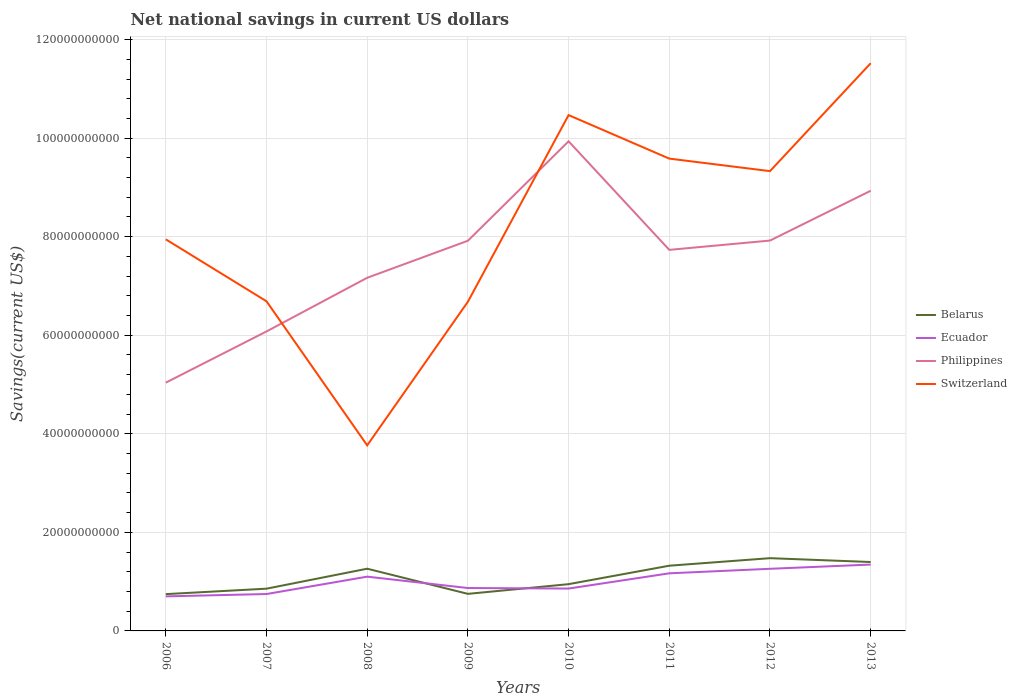Does the line corresponding to Ecuador intersect with the line corresponding to Philippines?
Give a very brief answer. No. Is the number of lines equal to the number of legend labels?
Provide a succinct answer. Yes. Across all years, what is the maximum net national savings in Belarus?
Keep it short and to the point. 7.47e+09. What is the total net national savings in Switzerland in the graph?
Offer a terse response. -3.79e+1. What is the difference between the highest and the second highest net national savings in Ecuador?
Ensure brevity in your answer.  6.46e+09. What is the difference between the highest and the lowest net national savings in Philippines?
Provide a succinct answer. 5. Is the net national savings in Philippines strictly greater than the net national savings in Switzerland over the years?
Keep it short and to the point. No. How many years are there in the graph?
Keep it short and to the point. 8. Does the graph contain any zero values?
Provide a succinct answer. No. Does the graph contain grids?
Make the answer very short. Yes. Where does the legend appear in the graph?
Your answer should be compact. Center right. How are the legend labels stacked?
Provide a succinct answer. Vertical. What is the title of the graph?
Your answer should be compact. Net national savings in current US dollars. What is the label or title of the Y-axis?
Make the answer very short. Savings(current US$). What is the Savings(current US$) in Belarus in 2006?
Your answer should be very brief. 7.47e+09. What is the Savings(current US$) in Ecuador in 2006?
Offer a terse response. 7.01e+09. What is the Savings(current US$) in Philippines in 2006?
Your answer should be very brief. 5.04e+1. What is the Savings(current US$) of Switzerland in 2006?
Keep it short and to the point. 7.95e+1. What is the Savings(current US$) in Belarus in 2007?
Ensure brevity in your answer.  8.57e+09. What is the Savings(current US$) of Ecuador in 2007?
Keep it short and to the point. 7.48e+09. What is the Savings(current US$) in Philippines in 2007?
Provide a succinct answer. 6.08e+1. What is the Savings(current US$) of Switzerland in 2007?
Give a very brief answer. 6.69e+1. What is the Savings(current US$) of Belarus in 2008?
Give a very brief answer. 1.26e+1. What is the Savings(current US$) of Ecuador in 2008?
Give a very brief answer. 1.10e+1. What is the Savings(current US$) of Philippines in 2008?
Your answer should be very brief. 7.17e+1. What is the Savings(current US$) in Switzerland in 2008?
Keep it short and to the point. 3.77e+1. What is the Savings(current US$) of Belarus in 2009?
Your answer should be compact. 7.52e+09. What is the Savings(current US$) of Ecuador in 2009?
Offer a very short reply. 8.71e+09. What is the Savings(current US$) of Philippines in 2009?
Make the answer very short. 7.92e+1. What is the Savings(current US$) in Switzerland in 2009?
Make the answer very short. 6.68e+1. What is the Savings(current US$) in Belarus in 2010?
Give a very brief answer. 9.49e+09. What is the Savings(current US$) of Ecuador in 2010?
Offer a terse response. 8.60e+09. What is the Savings(current US$) in Philippines in 2010?
Provide a succinct answer. 9.94e+1. What is the Savings(current US$) in Switzerland in 2010?
Give a very brief answer. 1.05e+11. What is the Savings(current US$) of Belarus in 2011?
Your answer should be very brief. 1.32e+1. What is the Savings(current US$) of Ecuador in 2011?
Make the answer very short. 1.17e+1. What is the Savings(current US$) in Philippines in 2011?
Offer a terse response. 7.73e+1. What is the Savings(current US$) of Switzerland in 2011?
Give a very brief answer. 9.58e+1. What is the Savings(current US$) of Belarus in 2012?
Offer a very short reply. 1.48e+1. What is the Savings(current US$) of Ecuador in 2012?
Offer a very short reply. 1.26e+1. What is the Savings(current US$) of Philippines in 2012?
Give a very brief answer. 7.92e+1. What is the Savings(current US$) of Switzerland in 2012?
Make the answer very short. 9.33e+1. What is the Savings(current US$) in Belarus in 2013?
Provide a short and direct response. 1.40e+1. What is the Savings(current US$) in Ecuador in 2013?
Provide a short and direct response. 1.35e+1. What is the Savings(current US$) of Philippines in 2013?
Provide a short and direct response. 8.93e+1. What is the Savings(current US$) in Switzerland in 2013?
Give a very brief answer. 1.15e+11. Across all years, what is the maximum Savings(current US$) in Belarus?
Give a very brief answer. 1.48e+1. Across all years, what is the maximum Savings(current US$) of Ecuador?
Ensure brevity in your answer.  1.35e+1. Across all years, what is the maximum Savings(current US$) of Philippines?
Your response must be concise. 9.94e+1. Across all years, what is the maximum Savings(current US$) of Switzerland?
Provide a short and direct response. 1.15e+11. Across all years, what is the minimum Savings(current US$) of Belarus?
Your response must be concise. 7.47e+09. Across all years, what is the minimum Savings(current US$) in Ecuador?
Offer a terse response. 7.01e+09. Across all years, what is the minimum Savings(current US$) of Philippines?
Keep it short and to the point. 5.04e+1. Across all years, what is the minimum Savings(current US$) in Switzerland?
Keep it short and to the point. 3.77e+1. What is the total Savings(current US$) in Belarus in the graph?
Your response must be concise. 8.77e+1. What is the total Savings(current US$) of Ecuador in the graph?
Make the answer very short. 8.06e+1. What is the total Savings(current US$) in Philippines in the graph?
Keep it short and to the point. 6.07e+11. What is the total Savings(current US$) in Switzerland in the graph?
Provide a succinct answer. 6.60e+11. What is the difference between the Savings(current US$) in Belarus in 2006 and that in 2007?
Your answer should be very brief. -1.11e+09. What is the difference between the Savings(current US$) in Ecuador in 2006 and that in 2007?
Provide a succinct answer. -4.76e+08. What is the difference between the Savings(current US$) in Philippines in 2006 and that in 2007?
Ensure brevity in your answer.  -1.04e+1. What is the difference between the Savings(current US$) of Switzerland in 2006 and that in 2007?
Provide a succinct answer. 1.26e+1. What is the difference between the Savings(current US$) of Belarus in 2006 and that in 2008?
Make the answer very short. -5.16e+09. What is the difference between the Savings(current US$) in Ecuador in 2006 and that in 2008?
Provide a succinct answer. -4.00e+09. What is the difference between the Savings(current US$) in Philippines in 2006 and that in 2008?
Make the answer very short. -2.13e+1. What is the difference between the Savings(current US$) of Switzerland in 2006 and that in 2008?
Give a very brief answer. 4.18e+1. What is the difference between the Savings(current US$) of Belarus in 2006 and that in 2009?
Give a very brief answer. -5.42e+07. What is the difference between the Savings(current US$) of Ecuador in 2006 and that in 2009?
Ensure brevity in your answer.  -1.70e+09. What is the difference between the Savings(current US$) of Philippines in 2006 and that in 2009?
Keep it short and to the point. -2.88e+1. What is the difference between the Savings(current US$) of Switzerland in 2006 and that in 2009?
Your answer should be very brief. 1.27e+1. What is the difference between the Savings(current US$) of Belarus in 2006 and that in 2010?
Provide a succinct answer. -2.02e+09. What is the difference between the Savings(current US$) of Ecuador in 2006 and that in 2010?
Your response must be concise. -1.59e+09. What is the difference between the Savings(current US$) in Philippines in 2006 and that in 2010?
Give a very brief answer. -4.90e+1. What is the difference between the Savings(current US$) of Switzerland in 2006 and that in 2010?
Give a very brief answer. -2.52e+1. What is the difference between the Savings(current US$) of Belarus in 2006 and that in 2011?
Ensure brevity in your answer.  -5.77e+09. What is the difference between the Savings(current US$) in Ecuador in 2006 and that in 2011?
Offer a very short reply. -4.68e+09. What is the difference between the Savings(current US$) in Philippines in 2006 and that in 2011?
Offer a terse response. -2.69e+1. What is the difference between the Savings(current US$) of Switzerland in 2006 and that in 2011?
Make the answer very short. -1.64e+1. What is the difference between the Savings(current US$) in Belarus in 2006 and that in 2012?
Make the answer very short. -7.30e+09. What is the difference between the Savings(current US$) of Ecuador in 2006 and that in 2012?
Provide a succinct answer. -5.60e+09. What is the difference between the Savings(current US$) of Philippines in 2006 and that in 2012?
Your answer should be compact. -2.88e+1. What is the difference between the Savings(current US$) in Switzerland in 2006 and that in 2012?
Keep it short and to the point. -1.38e+1. What is the difference between the Savings(current US$) of Belarus in 2006 and that in 2013?
Ensure brevity in your answer.  -6.52e+09. What is the difference between the Savings(current US$) of Ecuador in 2006 and that in 2013?
Give a very brief answer. -6.46e+09. What is the difference between the Savings(current US$) of Philippines in 2006 and that in 2013?
Your response must be concise. -3.89e+1. What is the difference between the Savings(current US$) in Switzerland in 2006 and that in 2013?
Provide a succinct answer. -3.57e+1. What is the difference between the Savings(current US$) of Belarus in 2007 and that in 2008?
Keep it short and to the point. -4.05e+09. What is the difference between the Savings(current US$) in Ecuador in 2007 and that in 2008?
Keep it short and to the point. -3.53e+09. What is the difference between the Savings(current US$) of Philippines in 2007 and that in 2008?
Make the answer very short. -1.09e+1. What is the difference between the Savings(current US$) of Switzerland in 2007 and that in 2008?
Provide a succinct answer. 2.92e+1. What is the difference between the Savings(current US$) in Belarus in 2007 and that in 2009?
Your answer should be compact. 1.05e+09. What is the difference between the Savings(current US$) in Ecuador in 2007 and that in 2009?
Provide a short and direct response. -1.22e+09. What is the difference between the Savings(current US$) of Philippines in 2007 and that in 2009?
Ensure brevity in your answer.  -1.84e+1. What is the difference between the Savings(current US$) of Switzerland in 2007 and that in 2009?
Offer a very short reply. 9.59e+07. What is the difference between the Savings(current US$) of Belarus in 2007 and that in 2010?
Your response must be concise. -9.17e+08. What is the difference between the Savings(current US$) in Ecuador in 2007 and that in 2010?
Provide a succinct answer. -1.11e+09. What is the difference between the Savings(current US$) of Philippines in 2007 and that in 2010?
Provide a short and direct response. -3.86e+1. What is the difference between the Savings(current US$) in Switzerland in 2007 and that in 2010?
Provide a short and direct response. -3.78e+1. What is the difference between the Savings(current US$) in Belarus in 2007 and that in 2011?
Your answer should be very brief. -4.66e+09. What is the difference between the Savings(current US$) of Ecuador in 2007 and that in 2011?
Your answer should be very brief. -4.20e+09. What is the difference between the Savings(current US$) of Philippines in 2007 and that in 2011?
Your answer should be compact. -1.66e+1. What is the difference between the Savings(current US$) of Switzerland in 2007 and that in 2011?
Keep it short and to the point. -2.89e+1. What is the difference between the Savings(current US$) in Belarus in 2007 and that in 2012?
Make the answer very short. -6.19e+09. What is the difference between the Savings(current US$) of Ecuador in 2007 and that in 2012?
Provide a succinct answer. -5.12e+09. What is the difference between the Savings(current US$) of Philippines in 2007 and that in 2012?
Your answer should be compact. -1.84e+1. What is the difference between the Savings(current US$) in Switzerland in 2007 and that in 2012?
Make the answer very short. -2.64e+1. What is the difference between the Savings(current US$) of Belarus in 2007 and that in 2013?
Give a very brief answer. -5.41e+09. What is the difference between the Savings(current US$) of Ecuador in 2007 and that in 2013?
Give a very brief answer. -5.98e+09. What is the difference between the Savings(current US$) of Philippines in 2007 and that in 2013?
Offer a terse response. -2.86e+1. What is the difference between the Savings(current US$) in Switzerland in 2007 and that in 2013?
Keep it short and to the point. -4.83e+1. What is the difference between the Savings(current US$) in Belarus in 2008 and that in 2009?
Your answer should be compact. 5.11e+09. What is the difference between the Savings(current US$) in Ecuador in 2008 and that in 2009?
Provide a succinct answer. 2.31e+09. What is the difference between the Savings(current US$) of Philippines in 2008 and that in 2009?
Offer a very short reply. -7.51e+09. What is the difference between the Savings(current US$) in Switzerland in 2008 and that in 2009?
Your answer should be very brief. -2.91e+1. What is the difference between the Savings(current US$) in Belarus in 2008 and that in 2010?
Give a very brief answer. 3.14e+09. What is the difference between the Savings(current US$) of Ecuador in 2008 and that in 2010?
Your answer should be compact. 2.42e+09. What is the difference between the Savings(current US$) in Philippines in 2008 and that in 2010?
Your response must be concise. -2.77e+1. What is the difference between the Savings(current US$) of Switzerland in 2008 and that in 2010?
Make the answer very short. -6.70e+1. What is the difference between the Savings(current US$) of Belarus in 2008 and that in 2011?
Your answer should be very brief. -6.08e+08. What is the difference between the Savings(current US$) of Ecuador in 2008 and that in 2011?
Keep it short and to the point. -6.76e+08. What is the difference between the Savings(current US$) of Philippines in 2008 and that in 2011?
Offer a terse response. -5.66e+09. What is the difference between the Savings(current US$) in Switzerland in 2008 and that in 2011?
Your answer should be compact. -5.82e+1. What is the difference between the Savings(current US$) of Belarus in 2008 and that in 2012?
Your answer should be compact. -2.14e+09. What is the difference between the Savings(current US$) in Ecuador in 2008 and that in 2012?
Ensure brevity in your answer.  -1.60e+09. What is the difference between the Savings(current US$) in Philippines in 2008 and that in 2012?
Your answer should be very brief. -7.55e+09. What is the difference between the Savings(current US$) in Switzerland in 2008 and that in 2012?
Your answer should be very brief. -5.57e+1. What is the difference between the Savings(current US$) in Belarus in 2008 and that in 2013?
Your response must be concise. -1.36e+09. What is the difference between the Savings(current US$) of Ecuador in 2008 and that in 2013?
Give a very brief answer. -2.45e+09. What is the difference between the Savings(current US$) of Philippines in 2008 and that in 2013?
Your response must be concise. -1.77e+1. What is the difference between the Savings(current US$) in Switzerland in 2008 and that in 2013?
Keep it short and to the point. -7.75e+1. What is the difference between the Savings(current US$) of Belarus in 2009 and that in 2010?
Keep it short and to the point. -1.97e+09. What is the difference between the Savings(current US$) of Ecuador in 2009 and that in 2010?
Provide a succinct answer. 1.08e+08. What is the difference between the Savings(current US$) in Philippines in 2009 and that in 2010?
Offer a terse response. -2.02e+1. What is the difference between the Savings(current US$) in Switzerland in 2009 and that in 2010?
Offer a very short reply. -3.79e+1. What is the difference between the Savings(current US$) of Belarus in 2009 and that in 2011?
Provide a succinct answer. -5.71e+09. What is the difference between the Savings(current US$) in Ecuador in 2009 and that in 2011?
Your response must be concise. -2.98e+09. What is the difference between the Savings(current US$) in Philippines in 2009 and that in 2011?
Your answer should be very brief. 1.85e+09. What is the difference between the Savings(current US$) of Switzerland in 2009 and that in 2011?
Provide a short and direct response. -2.90e+1. What is the difference between the Savings(current US$) of Belarus in 2009 and that in 2012?
Keep it short and to the point. -7.24e+09. What is the difference between the Savings(current US$) in Ecuador in 2009 and that in 2012?
Your answer should be very brief. -3.90e+09. What is the difference between the Savings(current US$) in Philippines in 2009 and that in 2012?
Give a very brief answer. -3.92e+07. What is the difference between the Savings(current US$) in Switzerland in 2009 and that in 2012?
Give a very brief answer. -2.65e+1. What is the difference between the Savings(current US$) of Belarus in 2009 and that in 2013?
Offer a terse response. -6.46e+09. What is the difference between the Savings(current US$) in Ecuador in 2009 and that in 2013?
Your response must be concise. -4.76e+09. What is the difference between the Savings(current US$) of Philippines in 2009 and that in 2013?
Your answer should be compact. -1.01e+1. What is the difference between the Savings(current US$) of Switzerland in 2009 and that in 2013?
Your answer should be very brief. -4.84e+1. What is the difference between the Savings(current US$) of Belarus in 2010 and that in 2011?
Your answer should be very brief. -3.74e+09. What is the difference between the Savings(current US$) in Ecuador in 2010 and that in 2011?
Ensure brevity in your answer.  -3.09e+09. What is the difference between the Savings(current US$) in Philippines in 2010 and that in 2011?
Offer a terse response. 2.20e+1. What is the difference between the Savings(current US$) of Switzerland in 2010 and that in 2011?
Offer a terse response. 8.83e+09. What is the difference between the Savings(current US$) in Belarus in 2010 and that in 2012?
Provide a short and direct response. -5.27e+09. What is the difference between the Savings(current US$) in Ecuador in 2010 and that in 2012?
Ensure brevity in your answer.  -4.01e+09. What is the difference between the Savings(current US$) in Philippines in 2010 and that in 2012?
Provide a short and direct response. 2.01e+1. What is the difference between the Savings(current US$) of Switzerland in 2010 and that in 2012?
Your response must be concise. 1.14e+1. What is the difference between the Savings(current US$) in Belarus in 2010 and that in 2013?
Offer a terse response. -4.49e+09. What is the difference between the Savings(current US$) in Ecuador in 2010 and that in 2013?
Your response must be concise. -4.87e+09. What is the difference between the Savings(current US$) in Philippines in 2010 and that in 2013?
Provide a succinct answer. 1.00e+1. What is the difference between the Savings(current US$) of Switzerland in 2010 and that in 2013?
Offer a very short reply. -1.05e+1. What is the difference between the Savings(current US$) of Belarus in 2011 and that in 2012?
Make the answer very short. -1.53e+09. What is the difference between the Savings(current US$) in Ecuador in 2011 and that in 2012?
Provide a short and direct response. -9.19e+08. What is the difference between the Savings(current US$) of Philippines in 2011 and that in 2012?
Offer a very short reply. -1.89e+09. What is the difference between the Savings(current US$) of Switzerland in 2011 and that in 2012?
Make the answer very short. 2.54e+09. What is the difference between the Savings(current US$) of Belarus in 2011 and that in 2013?
Ensure brevity in your answer.  -7.48e+08. What is the difference between the Savings(current US$) of Ecuador in 2011 and that in 2013?
Your response must be concise. -1.78e+09. What is the difference between the Savings(current US$) in Philippines in 2011 and that in 2013?
Offer a very short reply. -1.20e+1. What is the difference between the Savings(current US$) of Switzerland in 2011 and that in 2013?
Keep it short and to the point. -1.94e+1. What is the difference between the Savings(current US$) of Belarus in 2012 and that in 2013?
Your response must be concise. 7.80e+08. What is the difference between the Savings(current US$) of Ecuador in 2012 and that in 2013?
Give a very brief answer. -8.59e+08. What is the difference between the Savings(current US$) of Philippines in 2012 and that in 2013?
Your answer should be compact. -1.01e+1. What is the difference between the Savings(current US$) of Switzerland in 2012 and that in 2013?
Make the answer very short. -2.19e+1. What is the difference between the Savings(current US$) in Belarus in 2006 and the Savings(current US$) in Ecuador in 2007?
Offer a terse response. -1.79e+07. What is the difference between the Savings(current US$) of Belarus in 2006 and the Savings(current US$) of Philippines in 2007?
Provide a short and direct response. -5.33e+1. What is the difference between the Savings(current US$) in Belarus in 2006 and the Savings(current US$) in Switzerland in 2007?
Offer a terse response. -5.94e+1. What is the difference between the Savings(current US$) of Ecuador in 2006 and the Savings(current US$) of Philippines in 2007?
Your response must be concise. -5.38e+1. What is the difference between the Savings(current US$) of Ecuador in 2006 and the Savings(current US$) of Switzerland in 2007?
Provide a succinct answer. -5.99e+1. What is the difference between the Savings(current US$) in Philippines in 2006 and the Savings(current US$) in Switzerland in 2007?
Ensure brevity in your answer.  -1.65e+1. What is the difference between the Savings(current US$) of Belarus in 2006 and the Savings(current US$) of Ecuador in 2008?
Ensure brevity in your answer.  -3.55e+09. What is the difference between the Savings(current US$) of Belarus in 2006 and the Savings(current US$) of Philippines in 2008?
Make the answer very short. -6.42e+1. What is the difference between the Savings(current US$) in Belarus in 2006 and the Savings(current US$) in Switzerland in 2008?
Ensure brevity in your answer.  -3.02e+1. What is the difference between the Savings(current US$) in Ecuador in 2006 and the Savings(current US$) in Philippines in 2008?
Keep it short and to the point. -6.47e+1. What is the difference between the Savings(current US$) in Ecuador in 2006 and the Savings(current US$) in Switzerland in 2008?
Give a very brief answer. -3.06e+1. What is the difference between the Savings(current US$) in Philippines in 2006 and the Savings(current US$) in Switzerland in 2008?
Offer a terse response. 1.27e+1. What is the difference between the Savings(current US$) in Belarus in 2006 and the Savings(current US$) in Ecuador in 2009?
Keep it short and to the point. -1.24e+09. What is the difference between the Savings(current US$) in Belarus in 2006 and the Savings(current US$) in Philippines in 2009?
Your answer should be very brief. -7.17e+1. What is the difference between the Savings(current US$) in Belarus in 2006 and the Savings(current US$) in Switzerland in 2009?
Make the answer very short. -5.93e+1. What is the difference between the Savings(current US$) in Ecuador in 2006 and the Savings(current US$) in Philippines in 2009?
Your answer should be very brief. -7.22e+1. What is the difference between the Savings(current US$) in Ecuador in 2006 and the Savings(current US$) in Switzerland in 2009?
Make the answer very short. -5.98e+1. What is the difference between the Savings(current US$) in Philippines in 2006 and the Savings(current US$) in Switzerland in 2009?
Provide a short and direct response. -1.64e+1. What is the difference between the Savings(current US$) of Belarus in 2006 and the Savings(current US$) of Ecuador in 2010?
Your answer should be very brief. -1.13e+09. What is the difference between the Savings(current US$) of Belarus in 2006 and the Savings(current US$) of Philippines in 2010?
Give a very brief answer. -9.19e+1. What is the difference between the Savings(current US$) in Belarus in 2006 and the Savings(current US$) in Switzerland in 2010?
Offer a terse response. -9.72e+1. What is the difference between the Savings(current US$) of Ecuador in 2006 and the Savings(current US$) of Philippines in 2010?
Your response must be concise. -9.24e+1. What is the difference between the Savings(current US$) of Ecuador in 2006 and the Savings(current US$) of Switzerland in 2010?
Offer a terse response. -9.77e+1. What is the difference between the Savings(current US$) in Philippines in 2006 and the Savings(current US$) in Switzerland in 2010?
Give a very brief answer. -5.43e+1. What is the difference between the Savings(current US$) of Belarus in 2006 and the Savings(current US$) of Ecuador in 2011?
Your answer should be compact. -4.22e+09. What is the difference between the Savings(current US$) in Belarus in 2006 and the Savings(current US$) in Philippines in 2011?
Offer a terse response. -6.99e+1. What is the difference between the Savings(current US$) of Belarus in 2006 and the Savings(current US$) of Switzerland in 2011?
Keep it short and to the point. -8.84e+1. What is the difference between the Savings(current US$) of Ecuador in 2006 and the Savings(current US$) of Philippines in 2011?
Give a very brief answer. -7.03e+1. What is the difference between the Savings(current US$) of Ecuador in 2006 and the Savings(current US$) of Switzerland in 2011?
Your response must be concise. -8.88e+1. What is the difference between the Savings(current US$) of Philippines in 2006 and the Savings(current US$) of Switzerland in 2011?
Provide a short and direct response. -4.55e+1. What is the difference between the Savings(current US$) in Belarus in 2006 and the Savings(current US$) in Ecuador in 2012?
Provide a short and direct response. -5.14e+09. What is the difference between the Savings(current US$) in Belarus in 2006 and the Savings(current US$) in Philippines in 2012?
Your answer should be very brief. -7.17e+1. What is the difference between the Savings(current US$) of Belarus in 2006 and the Savings(current US$) of Switzerland in 2012?
Provide a succinct answer. -8.58e+1. What is the difference between the Savings(current US$) of Ecuador in 2006 and the Savings(current US$) of Philippines in 2012?
Your response must be concise. -7.22e+1. What is the difference between the Savings(current US$) in Ecuador in 2006 and the Savings(current US$) in Switzerland in 2012?
Provide a short and direct response. -8.63e+1. What is the difference between the Savings(current US$) of Philippines in 2006 and the Savings(current US$) of Switzerland in 2012?
Your answer should be compact. -4.29e+1. What is the difference between the Savings(current US$) of Belarus in 2006 and the Savings(current US$) of Ecuador in 2013?
Your answer should be compact. -6.00e+09. What is the difference between the Savings(current US$) in Belarus in 2006 and the Savings(current US$) in Philippines in 2013?
Offer a very short reply. -8.19e+1. What is the difference between the Savings(current US$) in Belarus in 2006 and the Savings(current US$) in Switzerland in 2013?
Offer a very short reply. -1.08e+11. What is the difference between the Savings(current US$) of Ecuador in 2006 and the Savings(current US$) of Philippines in 2013?
Your response must be concise. -8.23e+1. What is the difference between the Savings(current US$) in Ecuador in 2006 and the Savings(current US$) in Switzerland in 2013?
Your answer should be compact. -1.08e+11. What is the difference between the Savings(current US$) in Philippines in 2006 and the Savings(current US$) in Switzerland in 2013?
Make the answer very short. -6.48e+1. What is the difference between the Savings(current US$) in Belarus in 2007 and the Savings(current US$) in Ecuador in 2008?
Provide a succinct answer. -2.44e+09. What is the difference between the Savings(current US$) in Belarus in 2007 and the Savings(current US$) in Philippines in 2008?
Offer a terse response. -6.31e+1. What is the difference between the Savings(current US$) of Belarus in 2007 and the Savings(current US$) of Switzerland in 2008?
Offer a very short reply. -2.91e+1. What is the difference between the Savings(current US$) of Ecuador in 2007 and the Savings(current US$) of Philippines in 2008?
Give a very brief answer. -6.42e+1. What is the difference between the Savings(current US$) in Ecuador in 2007 and the Savings(current US$) in Switzerland in 2008?
Provide a succinct answer. -3.02e+1. What is the difference between the Savings(current US$) of Philippines in 2007 and the Savings(current US$) of Switzerland in 2008?
Keep it short and to the point. 2.31e+1. What is the difference between the Savings(current US$) in Belarus in 2007 and the Savings(current US$) in Ecuador in 2009?
Offer a very short reply. -1.33e+08. What is the difference between the Savings(current US$) in Belarus in 2007 and the Savings(current US$) in Philippines in 2009?
Your response must be concise. -7.06e+1. What is the difference between the Savings(current US$) in Belarus in 2007 and the Savings(current US$) in Switzerland in 2009?
Provide a succinct answer. -5.82e+1. What is the difference between the Savings(current US$) of Ecuador in 2007 and the Savings(current US$) of Philippines in 2009?
Your answer should be compact. -7.17e+1. What is the difference between the Savings(current US$) in Ecuador in 2007 and the Savings(current US$) in Switzerland in 2009?
Make the answer very short. -5.93e+1. What is the difference between the Savings(current US$) of Philippines in 2007 and the Savings(current US$) of Switzerland in 2009?
Your answer should be very brief. -6.03e+09. What is the difference between the Savings(current US$) in Belarus in 2007 and the Savings(current US$) in Ecuador in 2010?
Your answer should be compact. -2.52e+07. What is the difference between the Savings(current US$) of Belarus in 2007 and the Savings(current US$) of Philippines in 2010?
Provide a short and direct response. -9.08e+1. What is the difference between the Savings(current US$) in Belarus in 2007 and the Savings(current US$) in Switzerland in 2010?
Your answer should be very brief. -9.61e+1. What is the difference between the Savings(current US$) of Ecuador in 2007 and the Savings(current US$) of Philippines in 2010?
Make the answer very short. -9.19e+1. What is the difference between the Savings(current US$) in Ecuador in 2007 and the Savings(current US$) in Switzerland in 2010?
Keep it short and to the point. -9.72e+1. What is the difference between the Savings(current US$) in Philippines in 2007 and the Savings(current US$) in Switzerland in 2010?
Give a very brief answer. -4.39e+1. What is the difference between the Savings(current US$) in Belarus in 2007 and the Savings(current US$) in Ecuador in 2011?
Make the answer very short. -3.12e+09. What is the difference between the Savings(current US$) in Belarus in 2007 and the Savings(current US$) in Philippines in 2011?
Your answer should be compact. -6.88e+1. What is the difference between the Savings(current US$) in Belarus in 2007 and the Savings(current US$) in Switzerland in 2011?
Provide a succinct answer. -8.73e+1. What is the difference between the Savings(current US$) of Ecuador in 2007 and the Savings(current US$) of Philippines in 2011?
Ensure brevity in your answer.  -6.98e+1. What is the difference between the Savings(current US$) in Ecuador in 2007 and the Savings(current US$) in Switzerland in 2011?
Make the answer very short. -8.84e+1. What is the difference between the Savings(current US$) in Philippines in 2007 and the Savings(current US$) in Switzerland in 2011?
Offer a very short reply. -3.51e+1. What is the difference between the Savings(current US$) in Belarus in 2007 and the Savings(current US$) in Ecuador in 2012?
Provide a succinct answer. -4.04e+09. What is the difference between the Savings(current US$) of Belarus in 2007 and the Savings(current US$) of Philippines in 2012?
Provide a succinct answer. -7.06e+1. What is the difference between the Savings(current US$) of Belarus in 2007 and the Savings(current US$) of Switzerland in 2012?
Your answer should be very brief. -8.47e+1. What is the difference between the Savings(current US$) in Ecuador in 2007 and the Savings(current US$) in Philippines in 2012?
Your response must be concise. -7.17e+1. What is the difference between the Savings(current US$) in Ecuador in 2007 and the Savings(current US$) in Switzerland in 2012?
Keep it short and to the point. -8.58e+1. What is the difference between the Savings(current US$) in Philippines in 2007 and the Savings(current US$) in Switzerland in 2012?
Offer a very short reply. -3.25e+1. What is the difference between the Savings(current US$) in Belarus in 2007 and the Savings(current US$) in Ecuador in 2013?
Offer a terse response. -4.89e+09. What is the difference between the Savings(current US$) of Belarus in 2007 and the Savings(current US$) of Philippines in 2013?
Your answer should be very brief. -8.07e+1. What is the difference between the Savings(current US$) of Belarus in 2007 and the Savings(current US$) of Switzerland in 2013?
Give a very brief answer. -1.07e+11. What is the difference between the Savings(current US$) of Ecuador in 2007 and the Savings(current US$) of Philippines in 2013?
Make the answer very short. -8.18e+1. What is the difference between the Savings(current US$) in Ecuador in 2007 and the Savings(current US$) in Switzerland in 2013?
Provide a short and direct response. -1.08e+11. What is the difference between the Savings(current US$) of Philippines in 2007 and the Savings(current US$) of Switzerland in 2013?
Keep it short and to the point. -5.44e+1. What is the difference between the Savings(current US$) in Belarus in 2008 and the Savings(current US$) in Ecuador in 2009?
Provide a succinct answer. 3.92e+09. What is the difference between the Savings(current US$) in Belarus in 2008 and the Savings(current US$) in Philippines in 2009?
Your response must be concise. -6.65e+1. What is the difference between the Savings(current US$) of Belarus in 2008 and the Savings(current US$) of Switzerland in 2009?
Offer a terse response. -5.42e+1. What is the difference between the Savings(current US$) of Ecuador in 2008 and the Savings(current US$) of Philippines in 2009?
Keep it short and to the point. -6.82e+1. What is the difference between the Savings(current US$) in Ecuador in 2008 and the Savings(current US$) in Switzerland in 2009?
Provide a succinct answer. -5.58e+1. What is the difference between the Savings(current US$) in Philippines in 2008 and the Savings(current US$) in Switzerland in 2009?
Your answer should be compact. 4.86e+09. What is the difference between the Savings(current US$) in Belarus in 2008 and the Savings(current US$) in Ecuador in 2010?
Make the answer very short. 4.03e+09. What is the difference between the Savings(current US$) of Belarus in 2008 and the Savings(current US$) of Philippines in 2010?
Offer a very short reply. -8.67e+1. What is the difference between the Savings(current US$) of Belarus in 2008 and the Savings(current US$) of Switzerland in 2010?
Provide a succinct answer. -9.20e+1. What is the difference between the Savings(current US$) in Ecuador in 2008 and the Savings(current US$) in Philippines in 2010?
Your answer should be compact. -8.83e+1. What is the difference between the Savings(current US$) in Ecuador in 2008 and the Savings(current US$) in Switzerland in 2010?
Keep it short and to the point. -9.37e+1. What is the difference between the Savings(current US$) of Philippines in 2008 and the Savings(current US$) of Switzerland in 2010?
Your response must be concise. -3.30e+1. What is the difference between the Savings(current US$) of Belarus in 2008 and the Savings(current US$) of Ecuador in 2011?
Keep it short and to the point. 9.37e+08. What is the difference between the Savings(current US$) of Belarus in 2008 and the Savings(current US$) of Philippines in 2011?
Provide a short and direct response. -6.47e+1. What is the difference between the Savings(current US$) in Belarus in 2008 and the Savings(current US$) in Switzerland in 2011?
Keep it short and to the point. -8.32e+1. What is the difference between the Savings(current US$) in Ecuador in 2008 and the Savings(current US$) in Philippines in 2011?
Provide a succinct answer. -6.63e+1. What is the difference between the Savings(current US$) of Ecuador in 2008 and the Savings(current US$) of Switzerland in 2011?
Keep it short and to the point. -8.48e+1. What is the difference between the Savings(current US$) of Philippines in 2008 and the Savings(current US$) of Switzerland in 2011?
Offer a very short reply. -2.42e+1. What is the difference between the Savings(current US$) in Belarus in 2008 and the Savings(current US$) in Ecuador in 2012?
Offer a terse response. 1.78e+07. What is the difference between the Savings(current US$) in Belarus in 2008 and the Savings(current US$) in Philippines in 2012?
Offer a very short reply. -6.66e+1. What is the difference between the Savings(current US$) of Belarus in 2008 and the Savings(current US$) of Switzerland in 2012?
Your answer should be very brief. -8.07e+1. What is the difference between the Savings(current US$) of Ecuador in 2008 and the Savings(current US$) of Philippines in 2012?
Offer a terse response. -6.82e+1. What is the difference between the Savings(current US$) of Ecuador in 2008 and the Savings(current US$) of Switzerland in 2012?
Give a very brief answer. -8.23e+1. What is the difference between the Savings(current US$) of Philippines in 2008 and the Savings(current US$) of Switzerland in 2012?
Ensure brevity in your answer.  -2.16e+1. What is the difference between the Savings(current US$) of Belarus in 2008 and the Savings(current US$) of Ecuador in 2013?
Ensure brevity in your answer.  -8.41e+08. What is the difference between the Savings(current US$) in Belarus in 2008 and the Savings(current US$) in Philippines in 2013?
Keep it short and to the point. -7.67e+1. What is the difference between the Savings(current US$) of Belarus in 2008 and the Savings(current US$) of Switzerland in 2013?
Offer a terse response. -1.03e+11. What is the difference between the Savings(current US$) of Ecuador in 2008 and the Savings(current US$) of Philippines in 2013?
Your answer should be very brief. -7.83e+1. What is the difference between the Savings(current US$) of Ecuador in 2008 and the Savings(current US$) of Switzerland in 2013?
Make the answer very short. -1.04e+11. What is the difference between the Savings(current US$) in Philippines in 2008 and the Savings(current US$) in Switzerland in 2013?
Offer a very short reply. -4.35e+1. What is the difference between the Savings(current US$) in Belarus in 2009 and the Savings(current US$) in Ecuador in 2010?
Provide a short and direct response. -1.08e+09. What is the difference between the Savings(current US$) in Belarus in 2009 and the Savings(current US$) in Philippines in 2010?
Offer a very short reply. -9.18e+1. What is the difference between the Savings(current US$) of Belarus in 2009 and the Savings(current US$) of Switzerland in 2010?
Offer a terse response. -9.72e+1. What is the difference between the Savings(current US$) of Ecuador in 2009 and the Savings(current US$) of Philippines in 2010?
Keep it short and to the point. -9.07e+1. What is the difference between the Savings(current US$) in Ecuador in 2009 and the Savings(current US$) in Switzerland in 2010?
Your answer should be compact. -9.60e+1. What is the difference between the Savings(current US$) in Philippines in 2009 and the Savings(current US$) in Switzerland in 2010?
Make the answer very short. -2.55e+1. What is the difference between the Savings(current US$) of Belarus in 2009 and the Savings(current US$) of Ecuador in 2011?
Make the answer very short. -4.17e+09. What is the difference between the Savings(current US$) of Belarus in 2009 and the Savings(current US$) of Philippines in 2011?
Make the answer very short. -6.98e+1. What is the difference between the Savings(current US$) of Belarus in 2009 and the Savings(current US$) of Switzerland in 2011?
Your answer should be compact. -8.83e+1. What is the difference between the Savings(current US$) of Ecuador in 2009 and the Savings(current US$) of Philippines in 2011?
Provide a short and direct response. -6.86e+1. What is the difference between the Savings(current US$) of Ecuador in 2009 and the Savings(current US$) of Switzerland in 2011?
Your answer should be very brief. -8.71e+1. What is the difference between the Savings(current US$) of Philippines in 2009 and the Savings(current US$) of Switzerland in 2011?
Your answer should be very brief. -1.67e+1. What is the difference between the Savings(current US$) in Belarus in 2009 and the Savings(current US$) in Ecuador in 2012?
Your answer should be compact. -5.09e+09. What is the difference between the Savings(current US$) in Belarus in 2009 and the Savings(current US$) in Philippines in 2012?
Offer a very short reply. -7.17e+1. What is the difference between the Savings(current US$) of Belarus in 2009 and the Savings(current US$) of Switzerland in 2012?
Provide a succinct answer. -8.58e+1. What is the difference between the Savings(current US$) in Ecuador in 2009 and the Savings(current US$) in Philippines in 2012?
Provide a succinct answer. -7.05e+1. What is the difference between the Savings(current US$) in Ecuador in 2009 and the Savings(current US$) in Switzerland in 2012?
Your answer should be very brief. -8.46e+1. What is the difference between the Savings(current US$) in Philippines in 2009 and the Savings(current US$) in Switzerland in 2012?
Make the answer very short. -1.41e+1. What is the difference between the Savings(current US$) in Belarus in 2009 and the Savings(current US$) in Ecuador in 2013?
Offer a very short reply. -5.95e+09. What is the difference between the Savings(current US$) of Belarus in 2009 and the Savings(current US$) of Philippines in 2013?
Offer a terse response. -8.18e+1. What is the difference between the Savings(current US$) of Belarus in 2009 and the Savings(current US$) of Switzerland in 2013?
Your answer should be compact. -1.08e+11. What is the difference between the Savings(current US$) in Ecuador in 2009 and the Savings(current US$) in Philippines in 2013?
Offer a very short reply. -8.06e+1. What is the difference between the Savings(current US$) in Ecuador in 2009 and the Savings(current US$) in Switzerland in 2013?
Your answer should be compact. -1.06e+11. What is the difference between the Savings(current US$) in Philippines in 2009 and the Savings(current US$) in Switzerland in 2013?
Your answer should be compact. -3.60e+1. What is the difference between the Savings(current US$) in Belarus in 2010 and the Savings(current US$) in Ecuador in 2011?
Give a very brief answer. -2.20e+09. What is the difference between the Savings(current US$) of Belarus in 2010 and the Savings(current US$) of Philippines in 2011?
Offer a terse response. -6.78e+1. What is the difference between the Savings(current US$) in Belarus in 2010 and the Savings(current US$) in Switzerland in 2011?
Your answer should be very brief. -8.64e+1. What is the difference between the Savings(current US$) of Ecuador in 2010 and the Savings(current US$) of Philippines in 2011?
Your answer should be compact. -6.87e+1. What is the difference between the Savings(current US$) of Ecuador in 2010 and the Savings(current US$) of Switzerland in 2011?
Ensure brevity in your answer.  -8.72e+1. What is the difference between the Savings(current US$) of Philippines in 2010 and the Savings(current US$) of Switzerland in 2011?
Make the answer very short. 3.52e+09. What is the difference between the Savings(current US$) in Belarus in 2010 and the Savings(current US$) in Ecuador in 2012?
Your answer should be compact. -3.12e+09. What is the difference between the Savings(current US$) of Belarus in 2010 and the Savings(current US$) of Philippines in 2012?
Provide a short and direct response. -6.97e+1. What is the difference between the Savings(current US$) in Belarus in 2010 and the Savings(current US$) in Switzerland in 2012?
Give a very brief answer. -8.38e+1. What is the difference between the Savings(current US$) in Ecuador in 2010 and the Savings(current US$) in Philippines in 2012?
Provide a short and direct response. -7.06e+1. What is the difference between the Savings(current US$) in Ecuador in 2010 and the Savings(current US$) in Switzerland in 2012?
Your answer should be compact. -8.47e+1. What is the difference between the Savings(current US$) in Philippines in 2010 and the Savings(current US$) in Switzerland in 2012?
Provide a short and direct response. 6.06e+09. What is the difference between the Savings(current US$) of Belarus in 2010 and the Savings(current US$) of Ecuador in 2013?
Ensure brevity in your answer.  -3.98e+09. What is the difference between the Savings(current US$) of Belarus in 2010 and the Savings(current US$) of Philippines in 2013?
Your answer should be compact. -7.98e+1. What is the difference between the Savings(current US$) of Belarus in 2010 and the Savings(current US$) of Switzerland in 2013?
Your response must be concise. -1.06e+11. What is the difference between the Savings(current US$) of Ecuador in 2010 and the Savings(current US$) of Philippines in 2013?
Your response must be concise. -8.07e+1. What is the difference between the Savings(current US$) of Ecuador in 2010 and the Savings(current US$) of Switzerland in 2013?
Offer a very short reply. -1.07e+11. What is the difference between the Savings(current US$) of Philippines in 2010 and the Savings(current US$) of Switzerland in 2013?
Your response must be concise. -1.58e+1. What is the difference between the Savings(current US$) in Belarus in 2011 and the Savings(current US$) in Ecuador in 2012?
Provide a succinct answer. 6.25e+08. What is the difference between the Savings(current US$) of Belarus in 2011 and the Savings(current US$) of Philippines in 2012?
Keep it short and to the point. -6.60e+1. What is the difference between the Savings(current US$) in Belarus in 2011 and the Savings(current US$) in Switzerland in 2012?
Your answer should be compact. -8.01e+1. What is the difference between the Savings(current US$) in Ecuador in 2011 and the Savings(current US$) in Philippines in 2012?
Make the answer very short. -6.75e+1. What is the difference between the Savings(current US$) of Ecuador in 2011 and the Savings(current US$) of Switzerland in 2012?
Your answer should be very brief. -8.16e+1. What is the difference between the Savings(current US$) in Philippines in 2011 and the Savings(current US$) in Switzerland in 2012?
Offer a terse response. -1.60e+1. What is the difference between the Savings(current US$) of Belarus in 2011 and the Savings(current US$) of Ecuador in 2013?
Your answer should be very brief. -2.33e+08. What is the difference between the Savings(current US$) in Belarus in 2011 and the Savings(current US$) in Philippines in 2013?
Provide a succinct answer. -7.61e+1. What is the difference between the Savings(current US$) in Belarus in 2011 and the Savings(current US$) in Switzerland in 2013?
Provide a short and direct response. -1.02e+11. What is the difference between the Savings(current US$) in Ecuador in 2011 and the Savings(current US$) in Philippines in 2013?
Provide a succinct answer. -7.76e+1. What is the difference between the Savings(current US$) in Ecuador in 2011 and the Savings(current US$) in Switzerland in 2013?
Ensure brevity in your answer.  -1.04e+11. What is the difference between the Savings(current US$) in Philippines in 2011 and the Savings(current US$) in Switzerland in 2013?
Make the answer very short. -3.79e+1. What is the difference between the Savings(current US$) in Belarus in 2012 and the Savings(current US$) in Ecuador in 2013?
Your answer should be compact. 1.29e+09. What is the difference between the Savings(current US$) in Belarus in 2012 and the Savings(current US$) in Philippines in 2013?
Give a very brief answer. -7.46e+1. What is the difference between the Savings(current US$) in Belarus in 2012 and the Savings(current US$) in Switzerland in 2013?
Offer a terse response. -1.00e+11. What is the difference between the Savings(current US$) in Ecuador in 2012 and the Savings(current US$) in Philippines in 2013?
Your answer should be very brief. -7.67e+1. What is the difference between the Savings(current US$) of Ecuador in 2012 and the Savings(current US$) of Switzerland in 2013?
Make the answer very short. -1.03e+11. What is the difference between the Savings(current US$) of Philippines in 2012 and the Savings(current US$) of Switzerland in 2013?
Offer a very short reply. -3.60e+1. What is the average Savings(current US$) of Belarus per year?
Provide a succinct answer. 1.10e+1. What is the average Savings(current US$) in Ecuador per year?
Give a very brief answer. 1.01e+1. What is the average Savings(current US$) of Philippines per year?
Ensure brevity in your answer.  7.59e+1. What is the average Savings(current US$) in Switzerland per year?
Make the answer very short. 8.25e+1. In the year 2006, what is the difference between the Savings(current US$) in Belarus and Savings(current US$) in Ecuador?
Ensure brevity in your answer.  4.58e+08. In the year 2006, what is the difference between the Savings(current US$) of Belarus and Savings(current US$) of Philippines?
Make the answer very short. -4.29e+1. In the year 2006, what is the difference between the Savings(current US$) in Belarus and Savings(current US$) in Switzerland?
Your response must be concise. -7.20e+1. In the year 2006, what is the difference between the Savings(current US$) of Ecuador and Savings(current US$) of Philippines?
Your response must be concise. -4.34e+1. In the year 2006, what is the difference between the Savings(current US$) in Ecuador and Savings(current US$) in Switzerland?
Keep it short and to the point. -7.25e+1. In the year 2006, what is the difference between the Savings(current US$) of Philippines and Savings(current US$) of Switzerland?
Make the answer very short. -2.91e+1. In the year 2007, what is the difference between the Savings(current US$) in Belarus and Savings(current US$) in Ecuador?
Give a very brief answer. 1.09e+09. In the year 2007, what is the difference between the Savings(current US$) in Belarus and Savings(current US$) in Philippines?
Offer a very short reply. -5.22e+1. In the year 2007, what is the difference between the Savings(current US$) of Belarus and Savings(current US$) of Switzerland?
Your answer should be very brief. -5.83e+1. In the year 2007, what is the difference between the Savings(current US$) of Ecuador and Savings(current US$) of Philippines?
Your response must be concise. -5.33e+1. In the year 2007, what is the difference between the Savings(current US$) in Ecuador and Savings(current US$) in Switzerland?
Keep it short and to the point. -5.94e+1. In the year 2007, what is the difference between the Savings(current US$) of Philippines and Savings(current US$) of Switzerland?
Offer a terse response. -6.13e+09. In the year 2008, what is the difference between the Savings(current US$) in Belarus and Savings(current US$) in Ecuador?
Your answer should be very brief. 1.61e+09. In the year 2008, what is the difference between the Savings(current US$) of Belarus and Savings(current US$) of Philippines?
Offer a very short reply. -5.90e+1. In the year 2008, what is the difference between the Savings(current US$) in Belarus and Savings(current US$) in Switzerland?
Give a very brief answer. -2.50e+1. In the year 2008, what is the difference between the Savings(current US$) of Ecuador and Savings(current US$) of Philippines?
Provide a short and direct response. -6.06e+1. In the year 2008, what is the difference between the Savings(current US$) in Ecuador and Savings(current US$) in Switzerland?
Your response must be concise. -2.66e+1. In the year 2008, what is the difference between the Savings(current US$) of Philippines and Savings(current US$) of Switzerland?
Your answer should be compact. 3.40e+1. In the year 2009, what is the difference between the Savings(current US$) in Belarus and Savings(current US$) in Ecuador?
Offer a very short reply. -1.18e+09. In the year 2009, what is the difference between the Savings(current US$) in Belarus and Savings(current US$) in Philippines?
Ensure brevity in your answer.  -7.17e+1. In the year 2009, what is the difference between the Savings(current US$) of Belarus and Savings(current US$) of Switzerland?
Your response must be concise. -5.93e+1. In the year 2009, what is the difference between the Savings(current US$) in Ecuador and Savings(current US$) in Philippines?
Make the answer very short. -7.05e+1. In the year 2009, what is the difference between the Savings(current US$) of Ecuador and Savings(current US$) of Switzerland?
Your response must be concise. -5.81e+1. In the year 2009, what is the difference between the Savings(current US$) in Philippines and Savings(current US$) in Switzerland?
Make the answer very short. 1.24e+1. In the year 2010, what is the difference between the Savings(current US$) of Belarus and Savings(current US$) of Ecuador?
Provide a short and direct response. 8.92e+08. In the year 2010, what is the difference between the Savings(current US$) of Belarus and Savings(current US$) of Philippines?
Give a very brief answer. -8.99e+1. In the year 2010, what is the difference between the Savings(current US$) in Belarus and Savings(current US$) in Switzerland?
Provide a short and direct response. -9.52e+1. In the year 2010, what is the difference between the Savings(current US$) of Ecuador and Savings(current US$) of Philippines?
Offer a terse response. -9.08e+1. In the year 2010, what is the difference between the Savings(current US$) in Ecuador and Savings(current US$) in Switzerland?
Make the answer very short. -9.61e+1. In the year 2010, what is the difference between the Savings(current US$) in Philippines and Savings(current US$) in Switzerland?
Your answer should be compact. -5.32e+09. In the year 2011, what is the difference between the Savings(current US$) in Belarus and Savings(current US$) in Ecuador?
Provide a short and direct response. 1.54e+09. In the year 2011, what is the difference between the Savings(current US$) in Belarus and Savings(current US$) in Philippines?
Offer a very short reply. -6.41e+1. In the year 2011, what is the difference between the Savings(current US$) in Belarus and Savings(current US$) in Switzerland?
Ensure brevity in your answer.  -8.26e+1. In the year 2011, what is the difference between the Savings(current US$) of Ecuador and Savings(current US$) of Philippines?
Keep it short and to the point. -6.56e+1. In the year 2011, what is the difference between the Savings(current US$) in Ecuador and Savings(current US$) in Switzerland?
Provide a succinct answer. -8.42e+1. In the year 2011, what is the difference between the Savings(current US$) in Philippines and Savings(current US$) in Switzerland?
Give a very brief answer. -1.85e+1. In the year 2012, what is the difference between the Savings(current US$) of Belarus and Savings(current US$) of Ecuador?
Your answer should be very brief. 2.15e+09. In the year 2012, what is the difference between the Savings(current US$) of Belarus and Savings(current US$) of Philippines?
Make the answer very short. -6.45e+1. In the year 2012, what is the difference between the Savings(current US$) of Belarus and Savings(current US$) of Switzerland?
Ensure brevity in your answer.  -7.85e+1. In the year 2012, what is the difference between the Savings(current US$) in Ecuador and Savings(current US$) in Philippines?
Your answer should be compact. -6.66e+1. In the year 2012, what is the difference between the Savings(current US$) in Ecuador and Savings(current US$) in Switzerland?
Give a very brief answer. -8.07e+1. In the year 2012, what is the difference between the Savings(current US$) in Philippines and Savings(current US$) in Switzerland?
Your answer should be compact. -1.41e+1. In the year 2013, what is the difference between the Savings(current US$) of Belarus and Savings(current US$) of Ecuador?
Give a very brief answer. 5.15e+08. In the year 2013, what is the difference between the Savings(current US$) in Belarus and Savings(current US$) in Philippines?
Give a very brief answer. -7.53e+1. In the year 2013, what is the difference between the Savings(current US$) in Belarus and Savings(current US$) in Switzerland?
Your answer should be compact. -1.01e+11. In the year 2013, what is the difference between the Savings(current US$) of Ecuador and Savings(current US$) of Philippines?
Offer a terse response. -7.59e+1. In the year 2013, what is the difference between the Savings(current US$) in Ecuador and Savings(current US$) in Switzerland?
Provide a succinct answer. -1.02e+11. In the year 2013, what is the difference between the Savings(current US$) of Philippines and Savings(current US$) of Switzerland?
Ensure brevity in your answer.  -2.59e+1. What is the ratio of the Savings(current US$) in Belarus in 2006 to that in 2007?
Provide a short and direct response. 0.87. What is the ratio of the Savings(current US$) in Ecuador in 2006 to that in 2007?
Keep it short and to the point. 0.94. What is the ratio of the Savings(current US$) of Philippines in 2006 to that in 2007?
Provide a short and direct response. 0.83. What is the ratio of the Savings(current US$) of Switzerland in 2006 to that in 2007?
Keep it short and to the point. 1.19. What is the ratio of the Savings(current US$) in Belarus in 2006 to that in 2008?
Give a very brief answer. 0.59. What is the ratio of the Savings(current US$) in Ecuador in 2006 to that in 2008?
Your answer should be very brief. 0.64. What is the ratio of the Savings(current US$) of Philippines in 2006 to that in 2008?
Ensure brevity in your answer.  0.7. What is the ratio of the Savings(current US$) in Switzerland in 2006 to that in 2008?
Make the answer very short. 2.11. What is the ratio of the Savings(current US$) of Ecuador in 2006 to that in 2009?
Provide a succinct answer. 0.81. What is the ratio of the Savings(current US$) of Philippines in 2006 to that in 2009?
Your answer should be compact. 0.64. What is the ratio of the Savings(current US$) in Switzerland in 2006 to that in 2009?
Offer a terse response. 1.19. What is the ratio of the Savings(current US$) in Belarus in 2006 to that in 2010?
Make the answer very short. 0.79. What is the ratio of the Savings(current US$) in Ecuador in 2006 to that in 2010?
Offer a terse response. 0.82. What is the ratio of the Savings(current US$) of Philippines in 2006 to that in 2010?
Ensure brevity in your answer.  0.51. What is the ratio of the Savings(current US$) in Switzerland in 2006 to that in 2010?
Give a very brief answer. 0.76. What is the ratio of the Savings(current US$) of Belarus in 2006 to that in 2011?
Offer a very short reply. 0.56. What is the ratio of the Savings(current US$) in Ecuador in 2006 to that in 2011?
Offer a very short reply. 0.6. What is the ratio of the Savings(current US$) in Philippines in 2006 to that in 2011?
Provide a short and direct response. 0.65. What is the ratio of the Savings(current US$) in Switzerland in 2006 to that in 2011?
Your answer should be very brief. 0.83. What is the ratio of the Savings(current US$) in Belarus in 2006 to that in 2012?
Provide a short and direct response. 0.51. What is the ratio of the Savings(current US$) of Ecuador in 2006 to that in 2012?
Offer a terse response. 0.56. What is the ratio of the Savings(current US$) in Philippines in 2006 to that in 2012?
Offer a very short reply. 0.64. What is the ratio of the Savings(current US$) in Switzerland in 2006 to that in 2012?
Offer a very short reply. 0.85. What is the ratio of the Savings(current US$) of Belarus in 2006 to that in 2013?
Your response must be concise. 0.53. What is the ratio of the Savings(current US$) of Ecuador in 2006 to that in 2013?
Keep it short and to the point. 0.52. What is the ratio of the Savings(current US$) of Philippines in 2006 to that in 2013?
Your response must be concise. 0.56. What is the ratio of the Savings(current US$) of Switzerland in 2006 to that in 2013?
Provide a succinct answer. 0.69. What is the ratio of the Savings(current US$) in Belarus in 2007 to that in 2008?
Make the answer very short. 0.68. What is the ratio of the Savings(current US$) in Ecuador in 2007 to that in 2008?
Ensure brevity in your answer.  0.68. What is the ratio of the Savings(current US$) of Philippines in 2007 to that in 2008?
Offer a terse response. 0.85. What is the ratio of the Savings(current US$) in Switzerland in 2007 to that in 2008?
Offer a terse response. 1.78. What is the ratio of the Savings(current US$) of Belarus in 2007 to that in 2009?
Give a very brief answer. 1.14. What is the ratio of the Savings(current US$) in Ecuador in 2007 to that in 2009?
Ensure brevity in your answer.  0.86. What is the ratio of the Savings(current US$) of Philippines in 2007 to that in 2009?
Make the answer very short. 0.77. What is the ratio of the Savings(current US$) in Belarus in 2007 to that in 2010?
Make the answer very short. 0.9. What is the ratio of the Savings(current US$) of Ecuador in 2007 to that in 2010?
Keep it short and to the point. 0.87. What is the ratio of the Savings(current US$) of Philippines in 2007 to that in 2010?
Keep it short and to the point. 0.61. What is the ratio of the Savings(current US$) in Switzerland in 2007 to that in 2010?
Give a very brief answer. 0.64. What is the ratio of the Savings(current US$) of Belarus in 2007 to that in 2011?
Ensure brevity in your answer.  0.65. What is the ratio of the Savings(current US$) of Ecuador in 2007 to that in 2011?
Provide a succinct answer. 0.64. What is the ratio of the Savings(current US$) of Philippines in 2007 to that in 2011?
Your answer should be compact. 0.79. What is the ratio of the Savings(current US$) in Switzerland in 2007 to that in 2011?
Ensure brevity in your answer.  0.7. What is the ratio of the Savings(current US$) in Belarus in 2007 to that in 2012?
Offer a very short reply. 0.58. What is the ratio of the Savings(current US$) of Ecuador in 2007 to that in 2012?
Your response must be concise. 0.59. What is the ratio of the Savings(current US$) of Philippines in 2007 to that in 2012?
Ensure brevity in your answer.  0.77. What is the ratio of the Savings(current US$) in Switzerland in 2007 to that in 2012?
Your answer should be compact. 0.72. What is the ratio of the Savings(current US$) in Belarus in 2007 to that in 2013?
Your answer should be very brief. 0.61. What is the ratio of the Savings(current US$) of Ecuador in 2007 to that in 2013?
Your answer should be compact. 0.56. What is the ratio of the Savings(current US$) in Philippines in 2007 to that in 2013?
Provide a short and direct response. 0.68. What is the ratio of the Savings(current US$) in Switzerland in 2007 to that in 2013?
Provide a succinct answer. 0.58. What is the ratio of the Savings(current US$) in Belarus in 2008 to that in 2009?
Your response must be concise. 1.68. What is the ratio of the Savings(current US$) of Ecuador in 2008 to that in 2009?
Provide a succinct answer. 1.27. What is the ratio of the Savings(current US$) of Philippines in 2008 to that in 2009?
Provide a short and direct response. 0.91. What is the ratio of the Savings(current US$) in Switzerland in 2008 to that in 2009?
Provide a short and direct response. 0.56. What is the ratio of the Savings(current US$) of Belarus in 2008 to that in 2010?
Make the answer very short. 1.33. What is the ratio of the Savings(current US$) of Ecuador in 2008 to that in 2010?
Your response must be concise. 1.28. What is the ratio of the Savings(current US$) of Philippines in 2008 to that in 2010?
Your response must be concise. 0.72. What is the ratio of the Savings(current US$) in Switzerland in 2008 to that in 2010?
Your answer should be very brief. 0.36. What is the ratio of the Savings(current US$) in Belarus in 2008 to that in 2011?
Offer a very short reply. 0.95. What is the ratio of the Savings(current US$) of Ecuador in 2008 to that in 2011?
Make the answer very short. 0.94. What is the ratio of the Savings(current US$) of Philippines in 2008 to that in 2011?
Your response must be concise. 0.93. What is the ratio of the Savings(current US$) in Switzerland in 2008 to that in 2011?
Give a very brief answer. 0.39. What is the ratio of the Savings(current US$) of Belarus in 2008 to that in 2012?
Your answer should be compact. 0.86. What is the ratio of the Savings(current US$) in Ecuador in 2008 to that in 2012?
Your response must be concise. 0.87. What is the ratio of the Savings(current US$) in Philippines in 2008 to that in 2012?
Offer a terse response. 0.9. What is the ratio of the Savings(current US$) in Switzerland in 2008 to that in 2012?
Ensure brevity in your answer.  0.4. What is the ratio of the Savings(current US$) of Belarus in 2008 to that in 2013?
Your answer should be compact. 0.9. What is the ratio of the Savings(current US$) in Ecuador in 2008 to that in 2013?
Offer a very short reply. 0.82. What is the ratio of the Savings(current US$) of Philippines in 2008 to that in 2013?
Provide a succinct answer. 0.8. What is the ratio of the Savings(current US$) in Switzerland in 2008 to that in 2013?
Your response must be concise. 0.33. What is the ratio of the Savings(current US$) in Belarus in 2009 to that in 2010?
Keep it short and to the point. 0.79. What is the ratio of the Savings(current US$) of Ecuador in 2009 to that in 2010?
Provide a short and direct response. 1.01. What is the ratio of the Savings(current US$) in Philippines in 2009 to that in 2010?
Provide a succinct answer. 0.8. What is the ratio of the Savings(current US$) in Switzerland in 2009 to that in 2010?
Ensure brevity in your answer.  0.64. What is the ratio of the Savings(current US$) of Belarus in 2009 to that in 2011?
Give a very brief answer. 0.57. What is the ratio of the Savings(current US$) of Ecuador in 2009 to that in 2011?
Your answer should be compact. 0.74. What is the ratio of the Savings(current US$) of Philippines in 2009 to that in 2011?
Offer a very short reply. 1.02. What is the ratio of the Savings(current US$) of Switzerland in 2009 to that in 2011?
Keep it short and to the point. 0.7. What is the ratio of the Savings(current US$) of Belarus in 2009 to that in 2012?
Make the answer very short. 0.51. What is the ratio of the Savings(current US$) of Ecuador in 2009 to that in 2012?
Provide a short and direct response. 0.69. What is the ratio of the Savings(current US$) in Philippines in 2009 to that in 2012?
Your answer should be very brief. 1. What is the ratio of the Savings(current US$) in Switzerland in 2009 to that in 2012?
Provide a short and direct response. 0.72. What is the ratio of the Savings(current US$) in Belarus in 2009 to that in 2013?
Offer a very short reply. 0.54. What is the ratio of the Savings(current US$) in Ecuador in 2009 to that in 2013?
Ensure brevity in your answer.  0.65. What is the ratio of the Savings(current US$) of Philippines in 2009 to that in 2013?
Give a very brief answer. 0.89. What is the ratio of the Savings(current US$) in Switzerland in 2009 to that in 2013?
Ensure brevity in your answer.  0.58. What is the ratio of the Savings(current US$) in Belarus in 2010 to that in 2011?
Your answer should be very brief. 0.72. What is the ratio of the Savings(current US$) of Ecuador in 2010 to that in 2011?
Keep it short and to the point. 0.74. What is the ratio of the Savings(current US$) in Philippines in 2010 to that in 2011?
Provide a succinct answer. 1.28. What is the ratio of the Savings(current US$) of Switzerland in 2010 to that in 2011?
Offer a terse response. 1.09. What is the ratio of the Savings(current US$) in Belarus in 2010 to that in 2012?
Provide a succinct answer. 0.64. What is the ratio of the Savings(current US$) in Ecuador in 2010 to that in 2012?
Give a very brief answer. 0.68. What is the ratio of the Savings(current US$) of Philippines in 2010 to that in 2012?
Make the answer very short. 1.25. What is the ratio of the Savings(current US$) of Switzerland in 2010 to that in 2012?
Offer a very short reply. 1.12. What is the ratio of the Savings(current US$) in Belarus in 2010 to that in 2013?
Give a very brief answer. 0.68. What is the ratio of the Savings(current US$) in Ecuador in 2010 to that in 2013?
Keep it short and to the point. 0.64. What is the ratio of the Savings(current US$) in Philippines in 2010 to that in 2013?
Provide a succinct answer. 1.11. What is the ratio of the Savings(current US$) of Switzerland in 2010 to that in 2013?
Your response must be concise. 0.91. What is the ratio of the Savings(current US$) of Belarus in 2011 to that in 2012?
Give a very brief answer. 0.9. What is the ratio of the Savings(current US$) of Ecuador in 2011 to that in 2012?
Offer a very short reply. 0.93. What is the ratio of the Savings(current US$) of Philippines in 2011 to that in 2012?
Your answer should be very brief. 0.98. What is the ratio of the Savings(current US$) in Switzerland in 2011 to that in 2012?
Provide a short and direct response. 1.03. What is the ratio of the Savings(current US$) in Belarus in 2011 to that in 2013?
Your response must be concise. 0.95. What is the ratio of the Savings(current US$) in Ecuador in 2011 to that in 2013?
Give a very brief answer. 0.87. What is the ratio of the Savings(current US$) in Philippines in 2011 to that in 2013?
Provide a short and direct response. 0.87. What is the ratio of the Savings(current US$) of Switzerland in 2011 to that in 2013?
Provide a succinct answer. 0.83. What is the ratio of the Savings(current US$) in Belarus in 2012 to that in 2013?
Offer a terse response. 1.06. What is the ratio of the Savings(current US$) of Ecuador in 2012 to that in 2013?
Keep it short and to the point. 0.94. What is the ratio of the Savings(current US$) of Philippines in 2012 to that in 2013?
Give a very brief answer. 0.89. What is the ratio of the Savings(current US$) of Switzerland in 2012 to that in 2013?
Provide a short and direct response. 0.81. What is the difference between the highest and the second highest Savings(current US$) of Belarus?
Provide a short and direct response. 7.80e+08. What is the difference between the highest and the second highest Savings(current US$) of Ecuador?
Your answer should be very brief. 8.59e+08. What is the difference between the highest and the second highest Savings(current US$) in Philippines?
Your response must be concise. 1.00e+1. What is the difference between the highest and the second highest Savings(current US$) in Switzerland?
Provide a short and direct response. 1.05e+1. What is the difference between the highest and the lowest Savings(current US$) of Belarus?
Your answer should be compact. 7.30e+09. What is the difference between the highest and the lowest Savings(current US$) in Ecuador?
Give a very brief answer. 6.46e+09. What is the difference between the highest and the lowest Savings(current US$) of Philippines?
Your answer should be very brief. 4.90e+1. What is the difference between the highest and the lowest Savings(current US$) of Switzerland?
Give a very brief answer. 7.75e+1. 